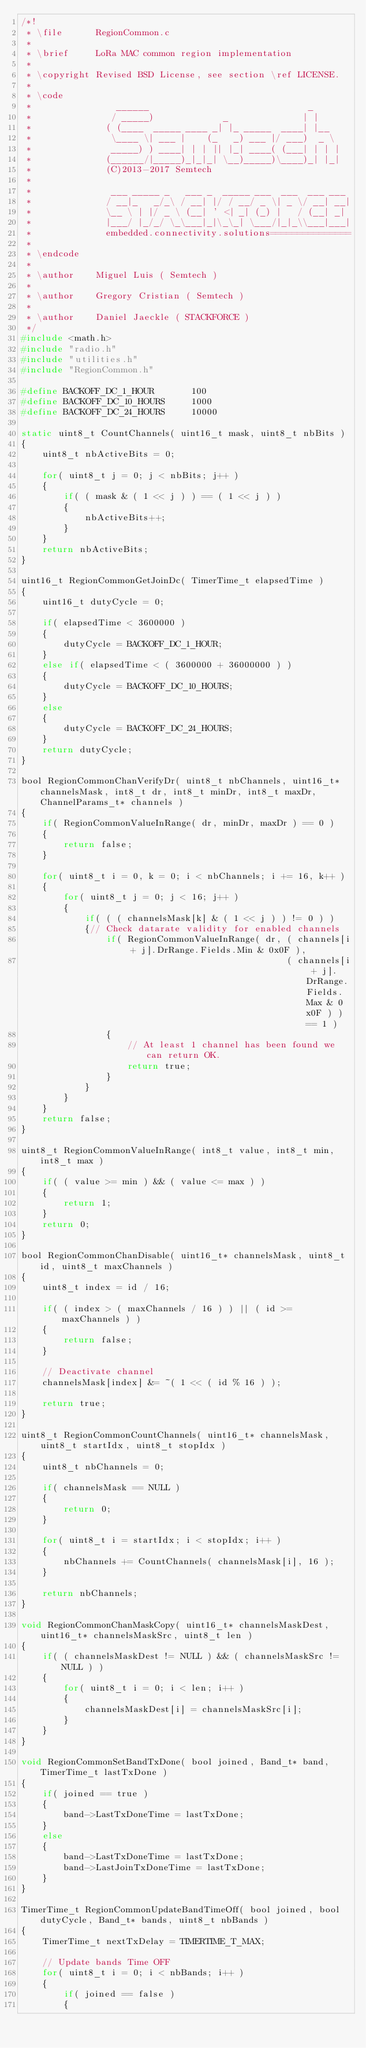<code> <loc_0><loc_0><loc_500><loc_500><_C_>/*!
 * \file      RegionCommon.c
 *
 * \brief     LoRa MAC common region implementation
 *
 * \copyright Revised BSD License, see section \ref LICENSE.
 *
 * \code
 *                ______                              _
 *               / _____)             _              | |
 *              ( (____  _____ ____ _| |_ _____  ____| |__
 *               \____ \| ___ |    (_   _) ___ |/ ___)  _ \
 *               _____) ) ____| | | || |_| ____( (___| | | |
 *              (______/|_____)_|_|_| \__)_____)\____)_| |_|
 *              (C)2013-2017 Semtech
 *
 *               ___ _____ _   ___ _  _____ ___  ___  ___ ___
 *              / __|_   _/_\ / __| |/ / __/ _ \| _ \/ __| __|
 *              \__ \ | |/ _ \ (__| ' <| _| (_) |   / (__| _|
 *              |___/ |_/_/ \_\___|_|\_\_| \___/|_|_\\___|___|
 *              embedded.connectivity.solutions===============
 *
 * \endcode
 *
 * \author    Miguel Luis ( Semtech )
 *
 * \author    Gregory Cristian ( Semtech )
 *
 * \author    Daniel Jaeckle ( STACKFORCE )
 */
#include <math.h>
#include "radio.h"
#include "utilities.h"
#include "RegionCommon.h"

#define BACKOFF_DC_1_HOUR       100
#define BACKOFF_DC_10_HOURS     1000
#define BACKOFF_DC_24_HOURS     10000

static uint8_t CountChannels( uint16_t mask, uint8_t nbBits )
{
    uint8_t nbActiveBits = 0;

    for( uint8_t j = 0; j < nbBits; j++ )
    {
        if( ( mask & ( 1 << j ) ) == ( 1 << j ) )
        {
            nbActiveBits++;
        }
    }
    return nbActiveBits;
}

uint16_t RegionCommonGetJoinDc( TimerTime_t elapsedTime )
{
    uint16_t dutyCycle = 0;

    if( elapsedTime < 3600000 )
    {
        dutyCycle = BACKOFF_DC_1_HOUR;
    }
    else if( elapsedTime < ( 3600000 + 36000000 ) )
    {
        dutyCycle = BACKOFF_DC_10_HOURS;
    }
    else
    {
        dutyCycle = BACKOFF_DC_24_HOURS;
    }
    return dutyCycle;
}

bool RegionCommonChanVerifyDr( uint8_t nbChannels, uint16_t* channelsMask, int8_t dr, int8_t minDr, int8_t maxDr, ChannelParams_t* channels )
{
    if( RegionCommonValueInRange( dr, minDr, maxDr ) == 0 )
    {
        return false;
    }

    for( uint8_t i = 0, k = 0; i < nbChannels; i += 16, k++ )
    {
        for( uint8_t j = 0; j < 16; j++ )
        {
            if( ( ( channelsMask[k] & ( 1 << j ) ) != 0 ) )
            {// Check datarate validity for enabled channels
                if( RegionCommonValueInRange( dr, ( channels[i + j].DrRange.Fields.Min & 0x0F ),
                                                  ( channels[i + j].DrRange.Fields.Max & 0x0F ) ) == 1 )
                {
                    // At least 1 channel has been found we can return OK.
                    return true;
                }
            }
        }
    }
    return false;
}

uint8_t RegionCommonValueInRange( int8_t value, int8_t min, int8_t max )
{
    if( ( value >= min ) && ( value <= max ) )
    {
        return 1;
    }
    return 0;
}

bool RegionCommonChanDisable( uint16_t* channelsMask, uint8_t id, uint8_t maxChannels )
{
    uint8_t index = id / 16;

    if( ( index > ( maxChannels / 16 ) ) || ( id >= maxChannels ) )
    {
        return false;
    }

    // Deactivate channel
    channelsMask[index] &= ~( 1 << ( id % 16 ) );

    return true;
}

uint8_t RegionCommonCountChannels( uint16_t* channelsMask, uint8_t startIdx, uint8_t stopIdx )
{
    uint8_t nbChannels = 0;

    if( channelsMask == NULL )
    {
        return 0;
    }

    for( uint8_t i = startIdx; i < stopIdx; i++ )
    {
        nbChannels += CountChannels( channelsMask[i], 16 );
    }

    return nbChannels;
}

void RegionCommonChanMaskCopy( uint16_t* channelsMaskDest, uint16_t* channelsMaskSrc, uint8_t len )
{
    if( ( channelsMaskDest != NULL ) && ( channelsMaskSrc != NULL ) )
    {
        for( uint8_t i = 0; i < len; i++ )
        {
            channelsMaskDest[i] = channelsMaskSrc[i];
        }
    }
}

void RegionCommonSetBandTxDone( bool joined, Band_t* band, TimerTime_t lastTxDone )
{
    if( joined == true )
    {
        band->LastTxDoneTime = lastTxDone;
    }
    else
    {
        band->LastTxDoneTime = lastTxDone;
        band->LastJoinTxDoneTime = lastTxDone;
    }
}

TimerTime_t RegionCommonUpdateBandTimeOff( bool joined, bool dutyCycle, Band_t* bands, uint8_t nbBands )
{
    TimerTime_t nextTxDelay = TIMERTIME_T_MAX;

    // Update bands Time OFF
    for( uint8_t i = 0; i < nbBands; i++ )
    {
        if( joined == false )
        {</code> 